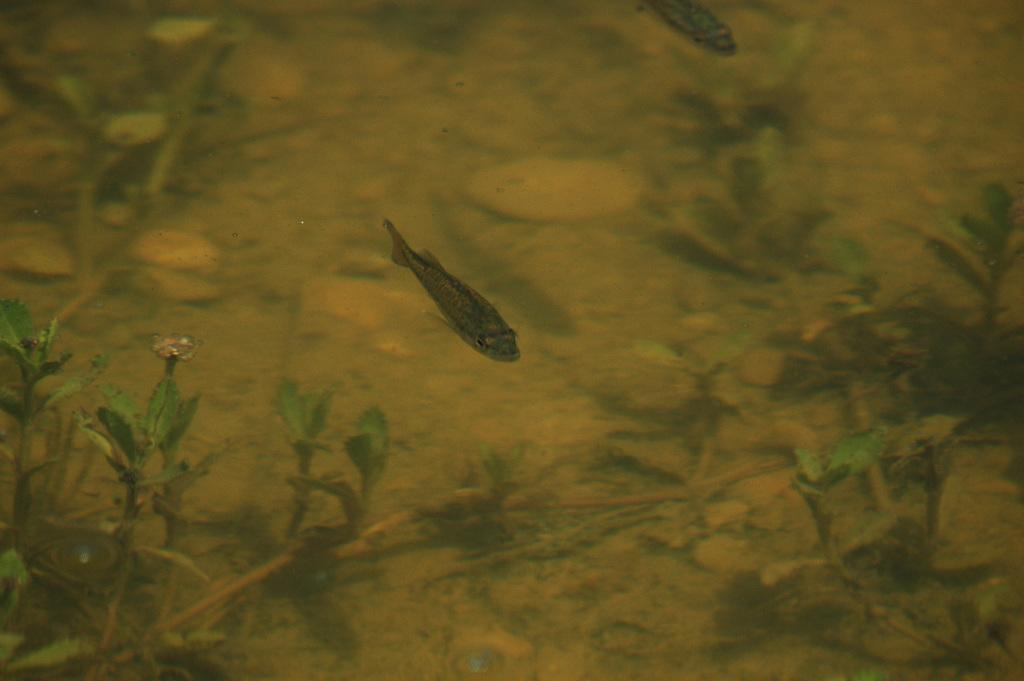What animals are present in the image? There are two fishes in the image. Where are the fishes located? The fishes are in the water. What other elements can be seen in the image? There are plants visible in the image. What color is the beggar's hat in the image? There is no beggar present in the image, so it is not possible to determine the color of their hat. 